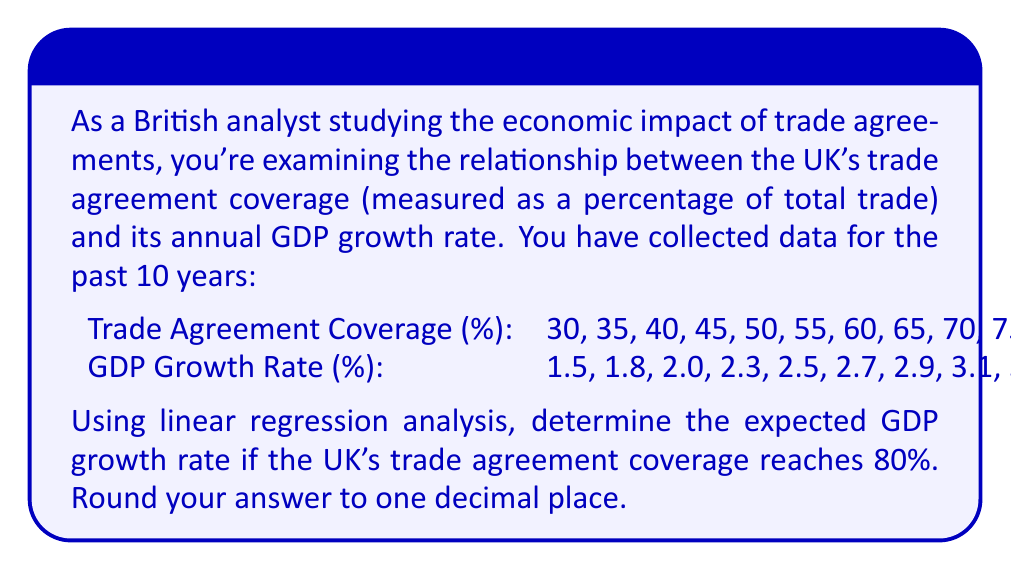Give your solution to this math problem. To solve this problem, we'll use linear regression analysis to find the relationship between trade agreement coverage (x) and GDP growth rate (y). Then, we'll use the resulting equation to predict the GDP growth rate for 80% coverage.

Step 1: Calculate the means of x and y
$$\bar{x} = \frac{\sum x_i}{n} = \frac{525}{10} = 52.5$$
$$\bar{y} = \frac{\sum y_i}{n} = \frac{25.6}{10} = 2.56$$

Step 2: Calculate the slope (m) of the regression line
$$m = \frac{\sum (x_i - \bar{x})(y_i - \bar{y})}{\sum (x_i - \bar{x})^2}$$

We need to calculate $\sum (x_i - \bar{x})(y_i - \bar{y})$ and $\sum (x_i - \bar{x})^2$:

$\sum (x_i - \bar{x})(y_i - \bar{y}) = 412.5$
$\sum (x_i - \bar{x})^2 = 2062.5$

$$m = \frac{412.5}{2062.5} = 0.2$$

Step 3: Calculate the y-intercept (b) of the regression line
$$b = \bar{y} - m\bar{x} = 2.56 - 0.2(52.5) = -7.94$$

Step 4: Write the regression equation
$$y = mx + b$$
$$y = 0.2x - 7.94$$

Step 5: Use the equation to predict the GDP growth rate when x = 80
$$y = 0.2(80) - 7.94 = 8.06$$

Step 6: Round the result to one decimal place
8.06 rounds to 8.1

Therefore, the expected GDP growth rate when the UK's trade agreement coverage reaches 80% is 8.1%.
Answer: 8.1% 